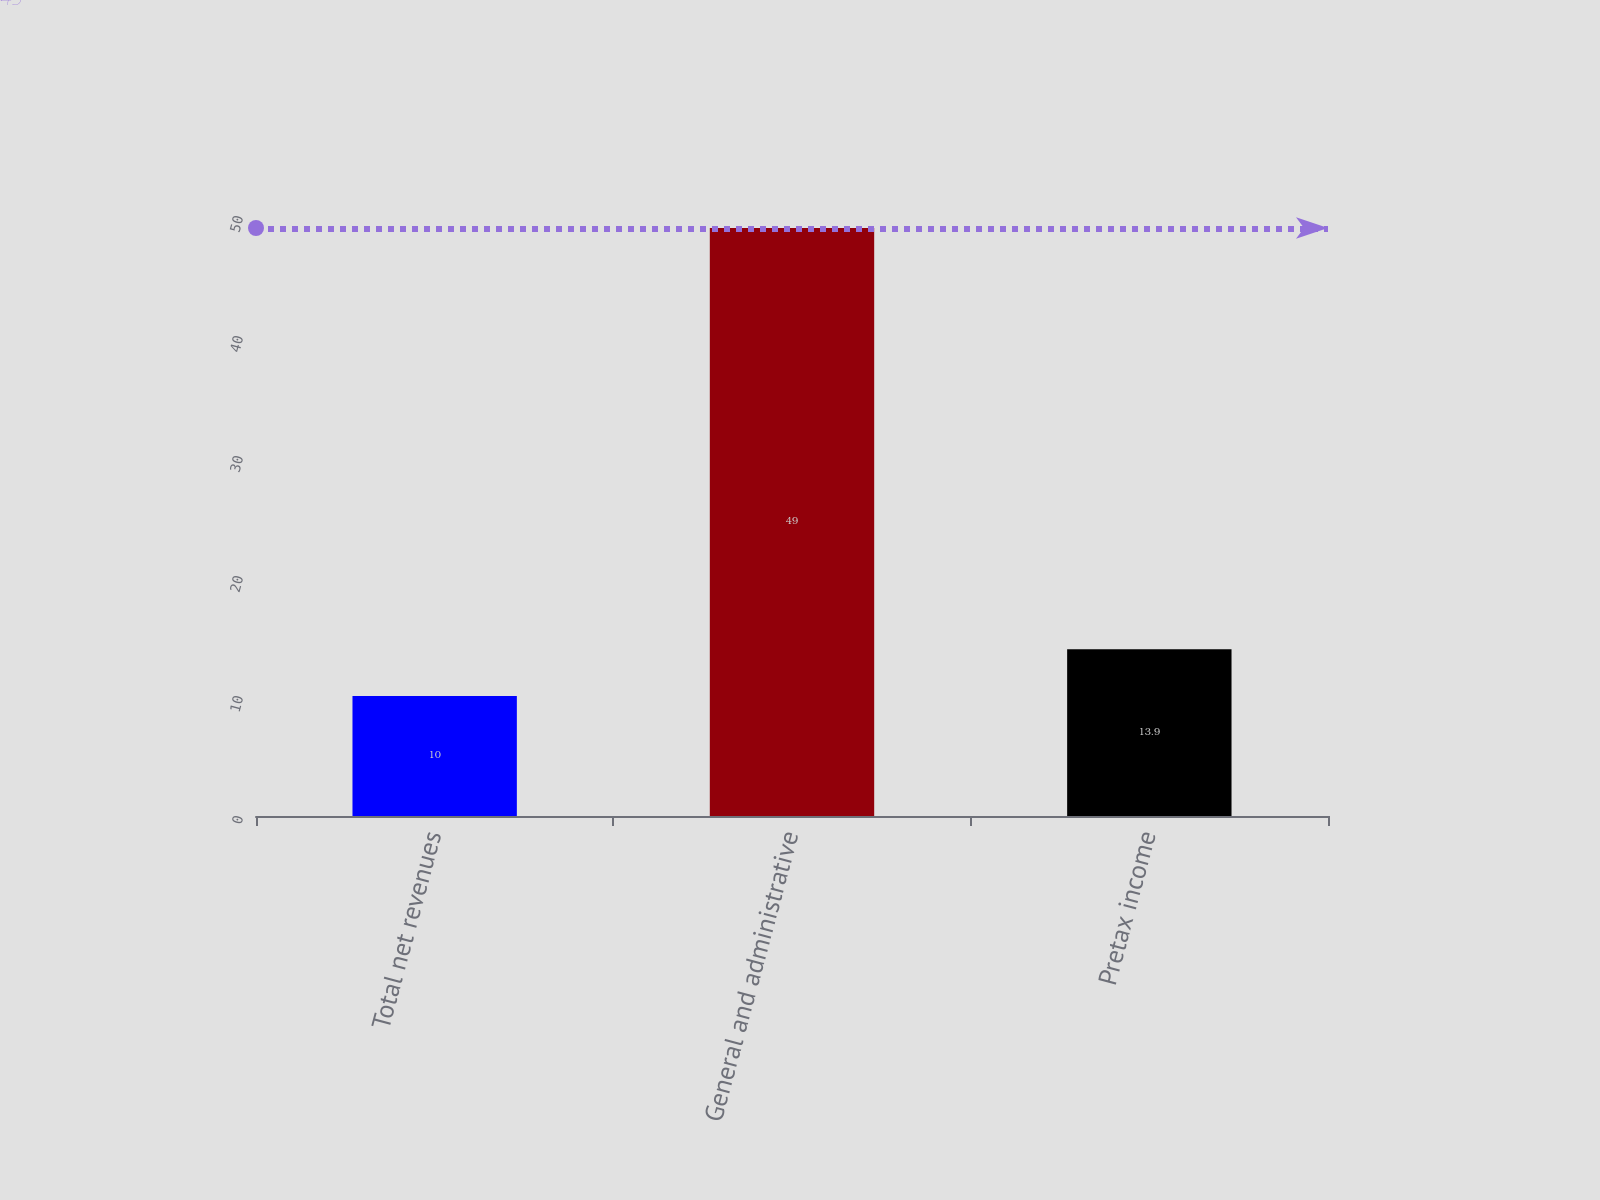Convert chart. <chart><loc_0><loc_0><loc_500><loc_500><bar_chart><fcel>Total net revenues<fcel>General and administrative<fcel>Pretax income<nl><fcel>10<fcel>49<fcel>13.9<nl></chart> 